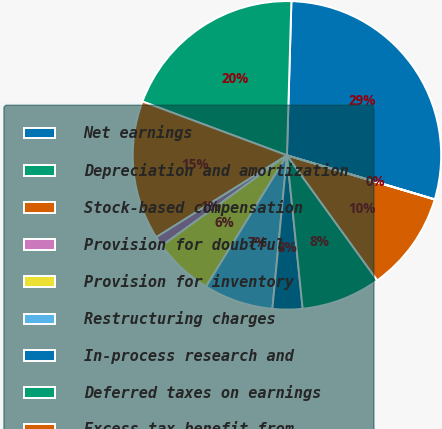Convert chart. <chart><loc_0><loc_0><loc_500><loc_500><pie_chart><fcel>Net earnings<fcel>Depreciation and amortization<fcel>Stock-based compensation<fcel>Provision for doubtful<fcel>Provision for inventory<fcel>Restructuring charges<fcel>In-process research and<fcel>Deferred taxes on earnings<fcel>Excess tax benefit from<fcel>Losses (gains) on investments<nl><fcel>29.15%<fcel>19.78%<fcel>14.58%<fcel>1.05%<fcel>6.25%<fcel>7.29%<fcel>3.13%<fcel>8.33%<fcel>10.42%<fcel>0.01%<nl></chart> 